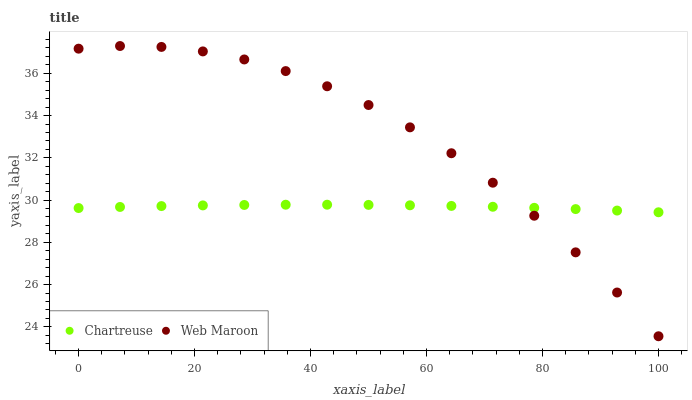Does Chartreuse have the minimum area under the curve?
Answer yes or no. Yes. Does Web Maroon have the maximum area under the curve?
Answer yes or no. Yes. Does Web Maroon have the minimum area under the curve?
Answer yes or no. No. Is Chartreuse the smoothest?
Answer yes or no. Yes. Is Web Maroon the roughest?
Answer yes or no. Yes. Is Web Maroon the smoothest?
Answer yes or no. No. Does Web Maroon have the lowest value?
Answer yes or no. Yes. Does Web Maroon have the highest value?
Answer yes or no. Yes. Does Chartreuse intersect Web Maroon?
Answer yes or no. Yes. Is Chartreuse less than Web Maroon?
Answer yes or no. No. Is Chartreuse greater than Web Maroon?
Answer yes or no. No. 